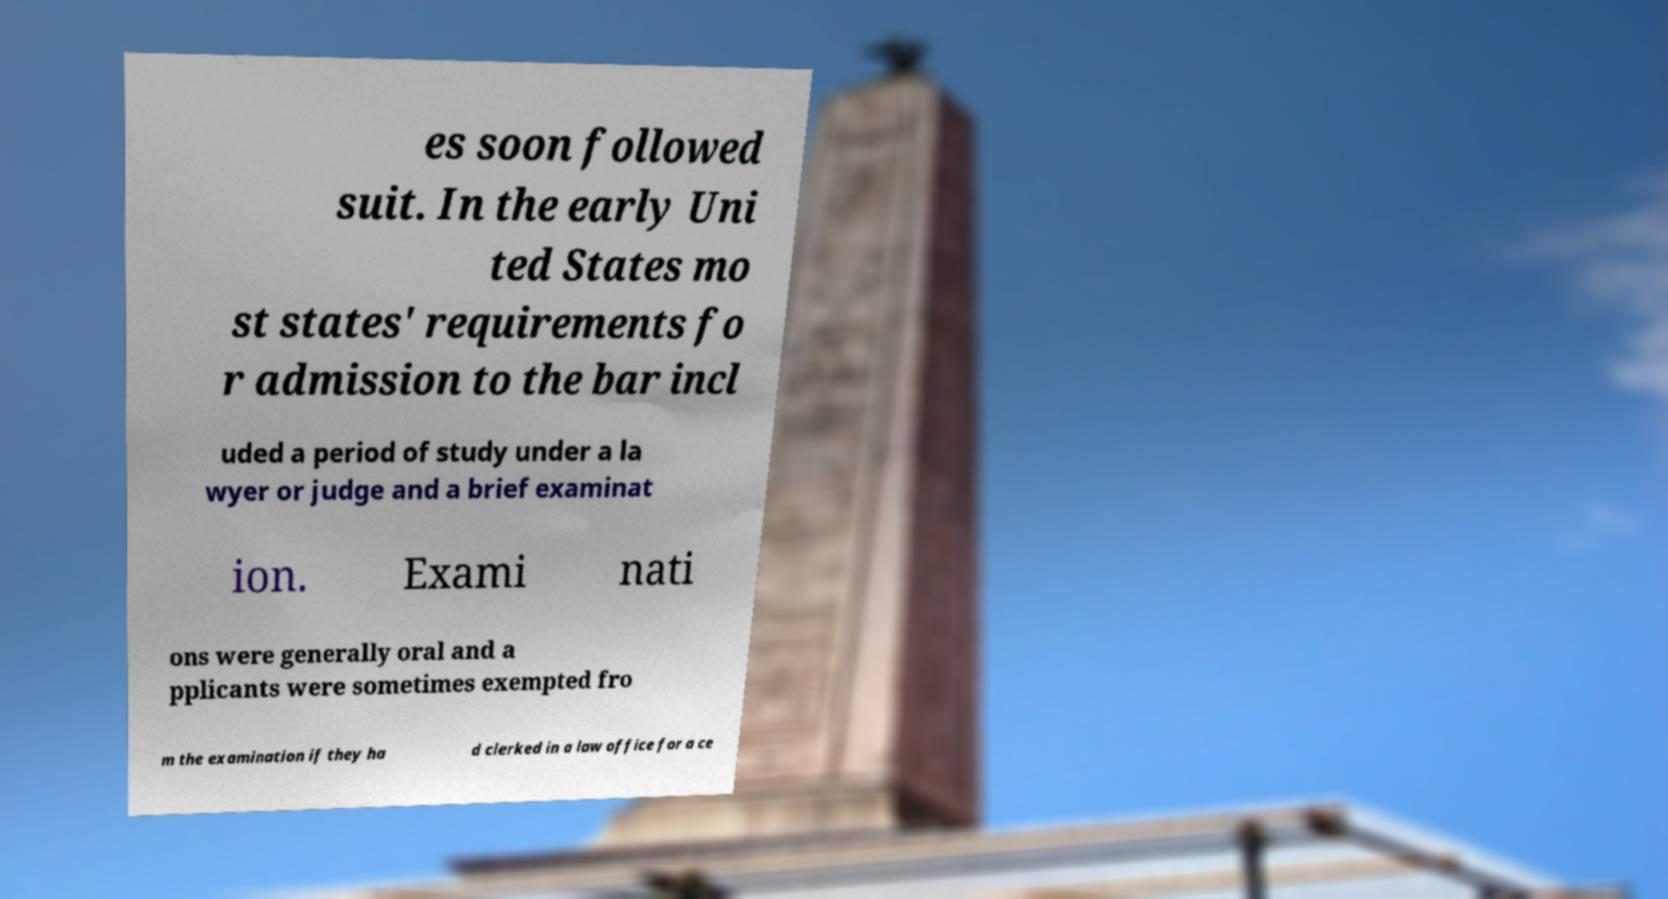For documentation purposes, I need the text within this image transcribed. Could you provide that? es soon followed suit. In the early Uni ted States mo st states' requirements fo r admission to the bar incl uded a period of study under a la wyer or judge and a brief examinat ion. Exami nati ons were generally oral and a pplicants were sometimes exempted fro m the examination if they ha d clerked in a law office for a ce 